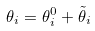<formula> <loc_0><loc_0><loc_500><loc_500>\theta _ { i } = \theta ^ { 0 } _ { i } + \tilde { \theta } _ { i }</formula> 